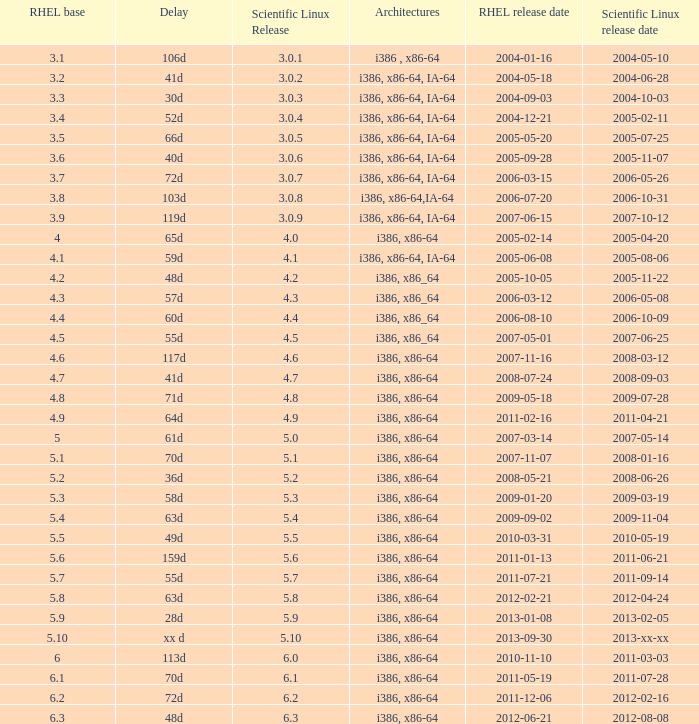When is the rhel release date when scientific linux release is 3.0.4 2004-12-21. 